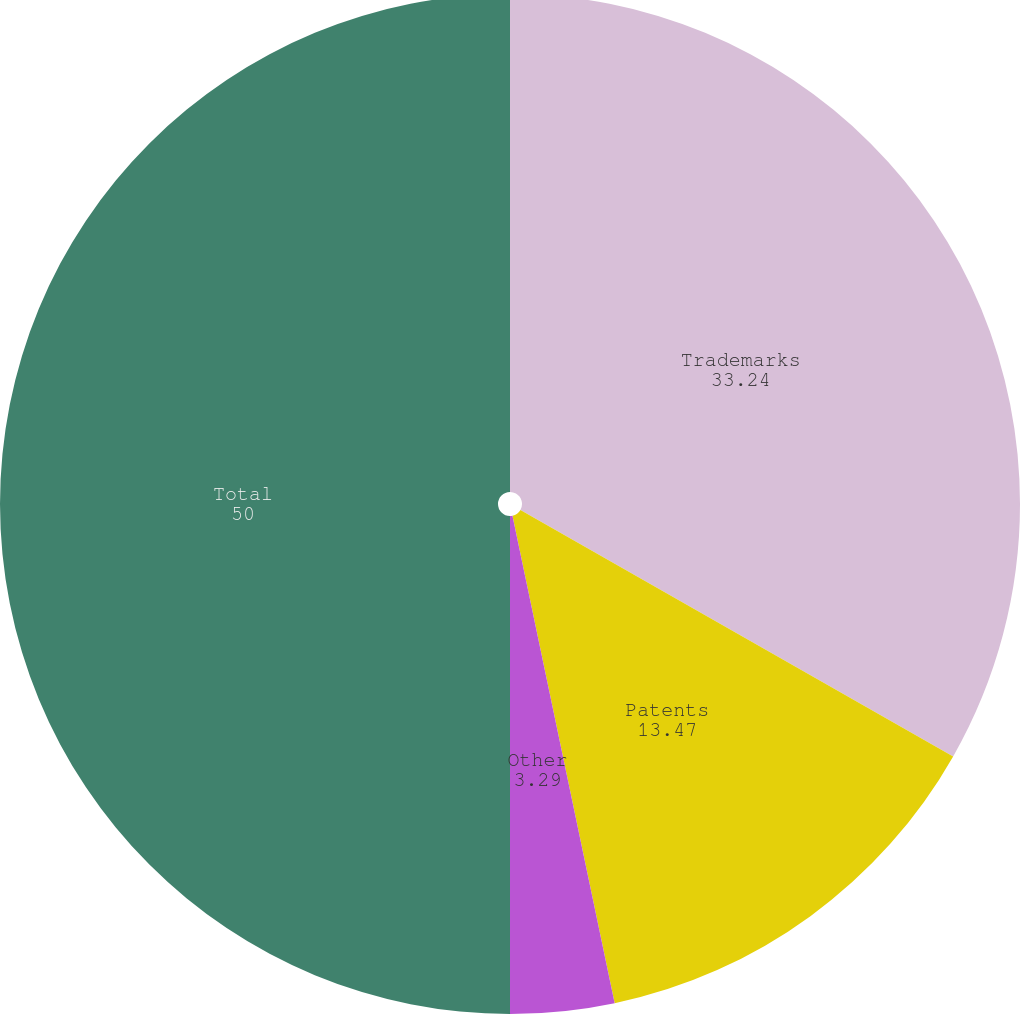Convert chart to OTSL. <chart><loc_0><loc_0><loc_500><loc_500><pie_chart><fcel>Trademarks<fcel>Patents<fcel>Other<fcel>Total<nl><fcel>33.24%<fcel>13.47%<fcel>3.29%<fcel>50.0%<nl></chart> 